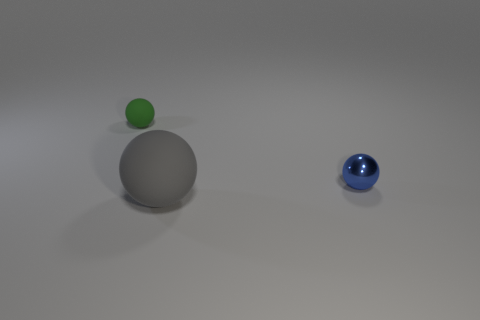Add 3 small yellow shiny cubes. How many objects exist? 6 Add 3 large gray matte objects. How many large gray matte objects are left? 4 Add 1 tiny red shiny spheres. How many tiny red shiny spheres exist? 1 Subtract 0 green cylinders. How many objects are left? 3 Subtract all large rubber balls. Subtract all green things. How many objects are left? 1 